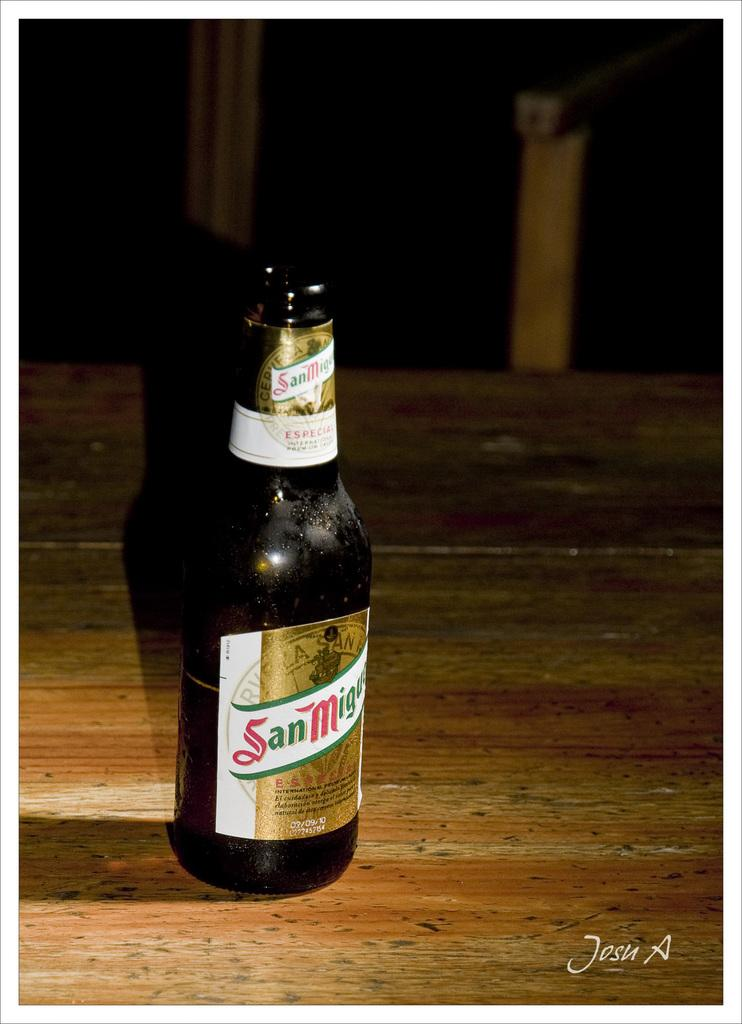<image>
Provide a brief description of the given image. A bottle of San Miguel ale on a wooden table. 